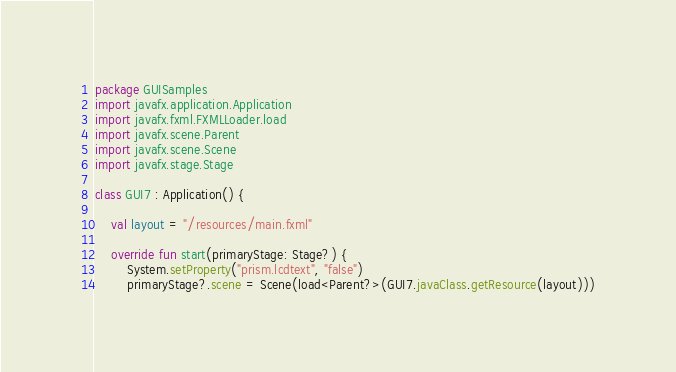<code> <loc_0><loc_0><loc_500><loc_500><_Kotlin_>package GUISamples
import javafx.application.Application
import javafx.fxml.FXMLLoader.load
import javafx.scene.Parent
import javafx.scene.Scene
import javafx.stage.Stage

class GUI7 : Application() {

    val layout = "/resources/main.fxml"

    override fun start(primaryStage: Stage?) {
        System.setProperty("prism.lcdtext", "false")
        primaryStage?.scene = Scene(load<Parent?>(GUI7.javaClass.getResource(layout)))</code> 